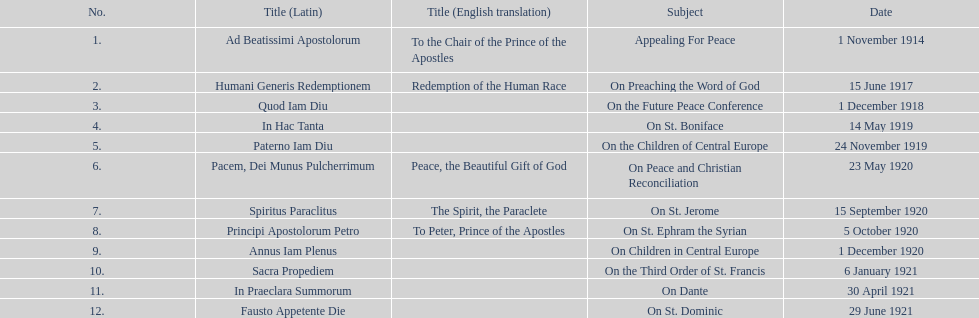In 1921, how many encyclicals were issued apart from those in january? 2. 